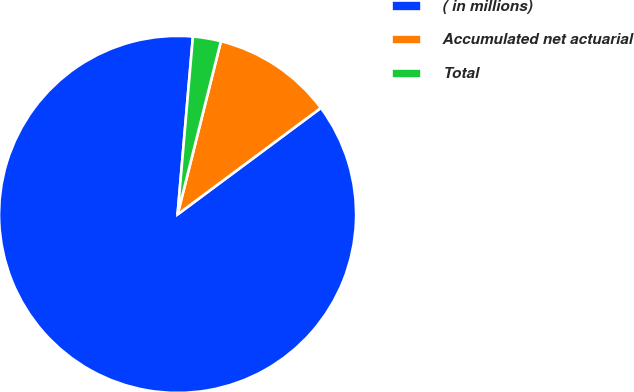Convert chart to OTSL. <chart><loc_0><loc_0><loc_500><loc_500><pie_chart><fcel>( in millions)<fcel>Accumulated net actuarial<fcel>Total<nl><fcel>86.54%<fcel>10.93%<fcel>2.53%<nl></chart> 